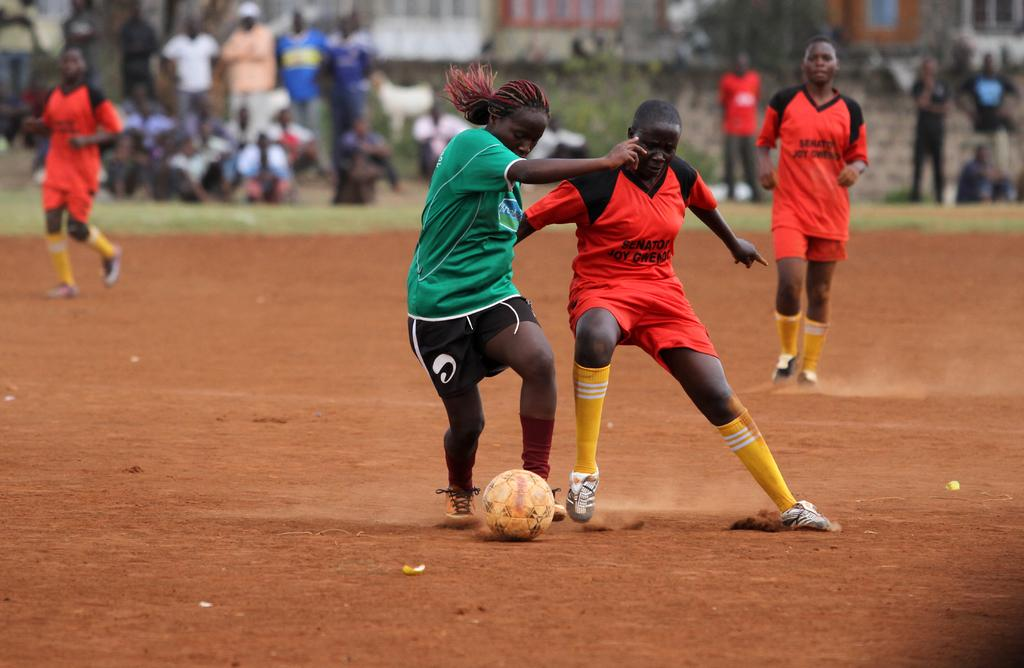What sport are the players engaged in within the image? The players are playing football in the image. Where is the football game taking place? The football game is taking place on a ground. What can be observed in the background of the image? There are people sitting and standing in the background of the image. How is the background of the image depicted? The background is blurred. What type of clover is growing on the football ground in the image? There is no clover visible on the football ground in the image. How does the football game contribute to the health of the players in the image? The image does not provide information about the health of the players or the impact of the game on their health. 